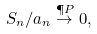Convert formula to latex. <formula><loc_0><loc_0><loc_500><loc_500>S _ { n } / a _ { n } \stackrel { \P P } { \to } 0 ,</formula> 